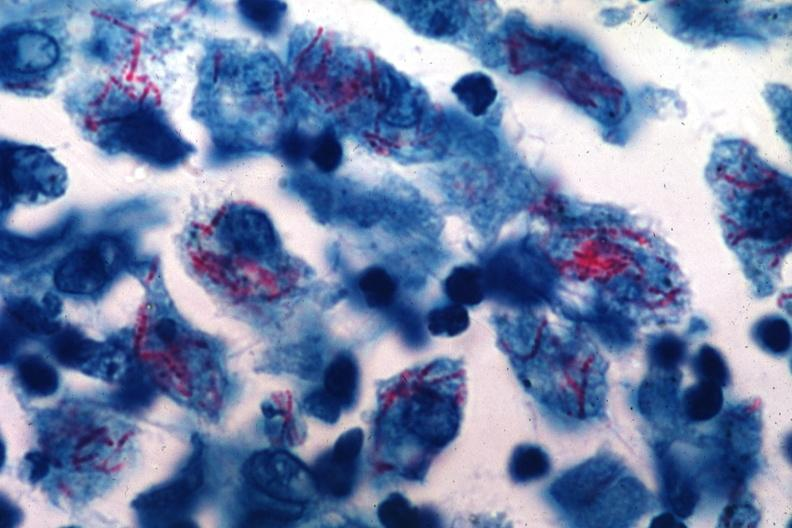what was an early case of mycobacterium intracellulare infection too many organisms for old time tb?
Answer the question using a single word or phrase. This 